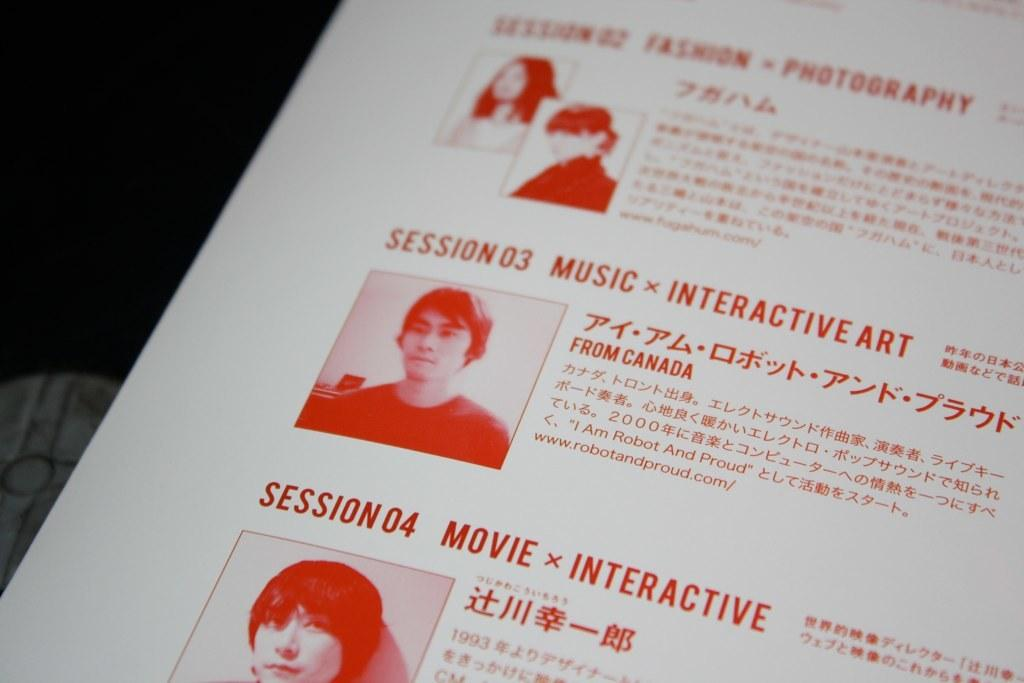What is present on the paper in the image? There are images and writing on the paper in the image. Can you describe the images on the paper? Unfortunately, the specific images on the paper cannot be described without more information. What type of content is written on the paper? The writing on the paper cannot be determined without more information. What type of animal can be seen swimming in the wilderness in the image? There is no animal or wilderness present in the image; it only features a paper with images and writing. 